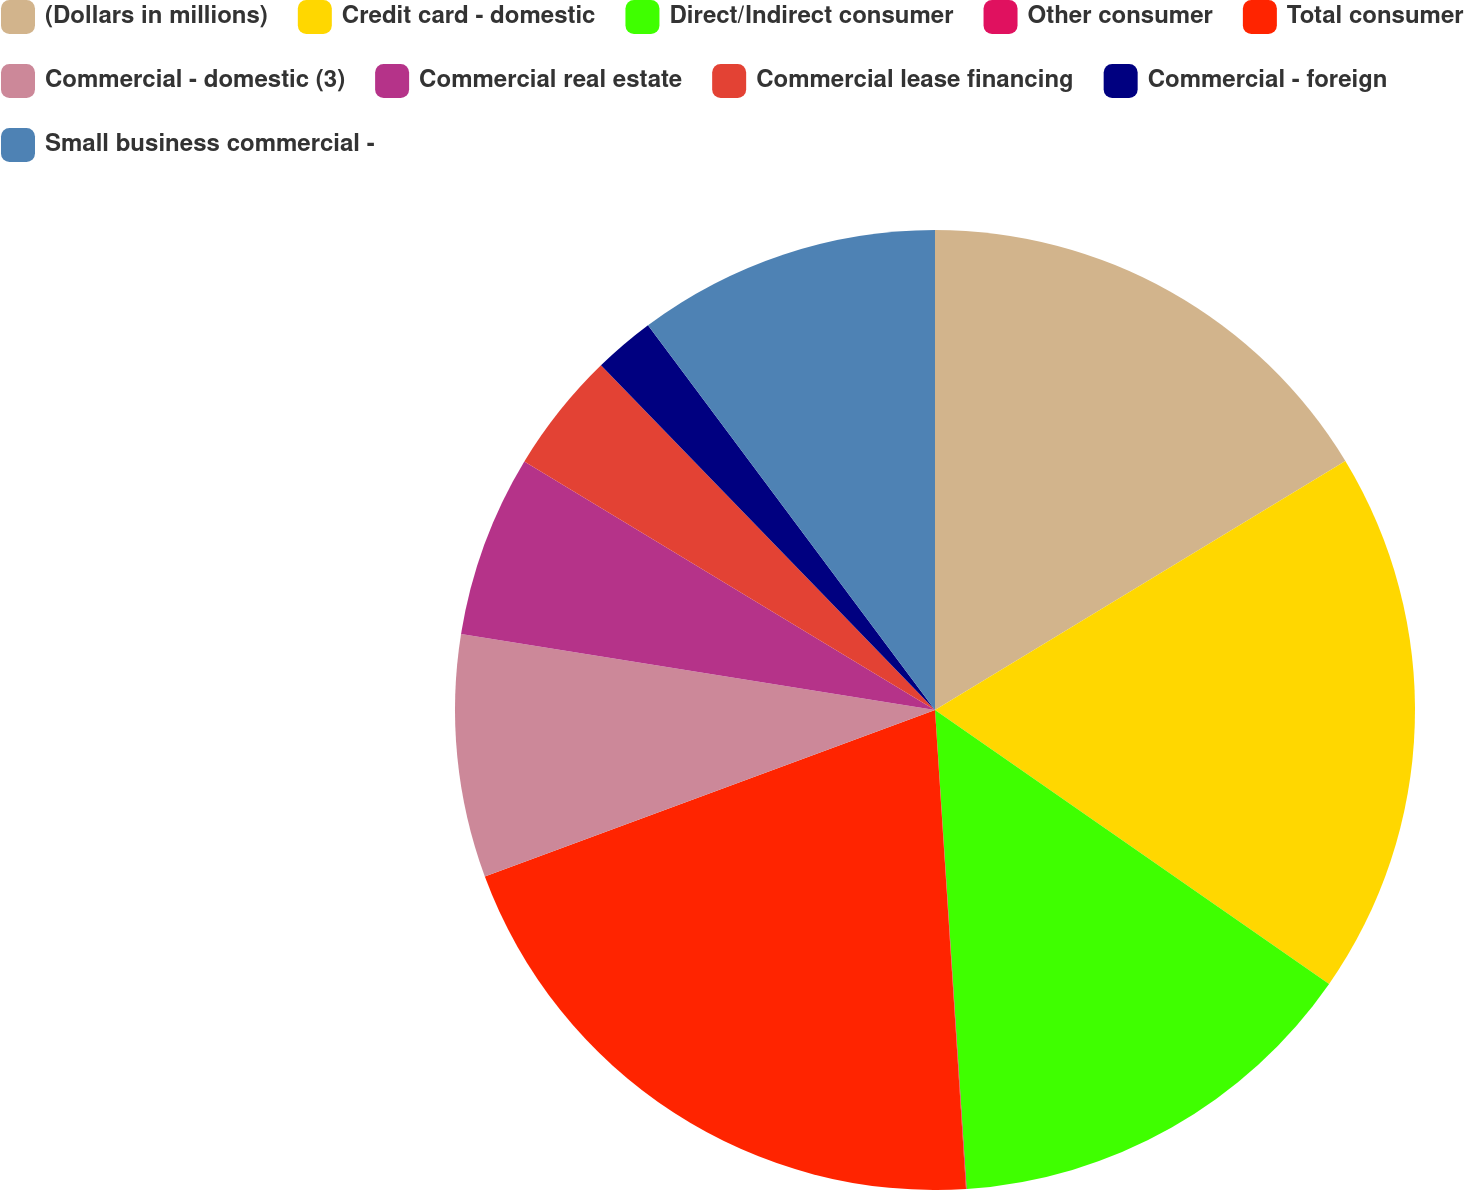Convert chart. <chart><loc_0><loc_0><loc_500><loc_500><pie_chart><fcel>(Dollars in millions)<fcel>Credit card - domestic<fcel>Direct/Indirect consumer<fcel>Other consumer<fcel>Total consumer<fcel>Commercial - domestic (3)<fcel>Commercial real estate<fcel>Commercial lease financing<fcel>Commercial - foreign<fcel>Small business commercial -<nl><fcel>16.32%<fcel>18.35%<fcel>14.28%<fcel>0.02%<fcel>20.39%<fcel>8.17%<fcel>6.13%<fcel>4.09%<fcel>2.05%<fcel>10.2%<nl></chart> 